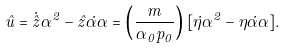Convert formula to latex. <formula><loc_0><loc_0><loc_500><loc_500>\hat { u } = \dot { \hat { z } } \alpha ^ { 2 } - \hat { z } \dot { \alpha } \alpha = \left ( \frac { m } { \alpha _ { 0 } p _ { 0 } } \right ) [ \dot { \eta } \alpha ^ { 2 } - \eta \dot { \alpha } \alpha ] .</formula> 